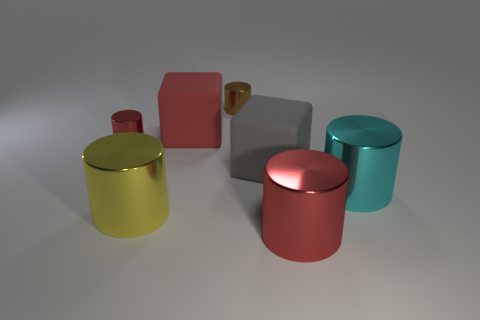What is the color of the big thing behind the rubber object that is to the right of the brown metal thing?
Your answer should be compact. Red. Do the red shiny object that is in front of the small red cylinder and the gray object have the same shape?
Offer a very short reply. No. How many objects are both behind the yellow metallic cylinder and left of the red rubber cube?
Offer a terse response. 1. There is a big shiny thing that is right of the thing in front of the yellow object that is left of the big red shiny cylinder; what is its color?
Your answer should be compact. Cyan. What number of red metal objects are left of the big metal thing in front of the yellow object?
Offer a very short reply. 1. What number of other things are there of the same shape as the small red metal thing?
Your response must be concise. 4. How many objects are small cyan blocks or red cubes behind the small red cylinder?
Your response must be concise. 1. Is the number of large yellow cylinders that are on the right side of the large gray thing greater than the number of tiny red cylinders in front of the small brown object?
Offer a terse response. No. What is the shape of the object on the right side of the red shiny thing in front of the red metal cylinder behind the cyan shiny object?
Make the answer very short. Cylinder. What is the shape of the cyan shiny thing that is on the right side of the matte cube that is on the left side of the gray object?
Offer a very short reply. Cylinder. 